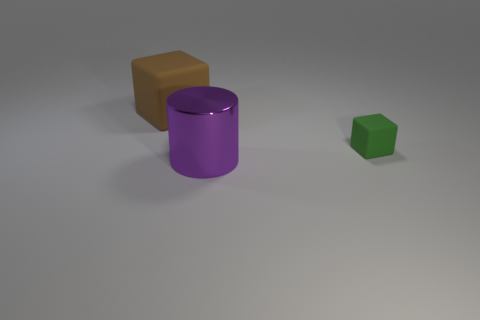The purple metal thing that is the same size as the brown rubber object is what shape?
Your response must be concise. Cylinder. Is there a purple shiny block of the same size as the brown cube?
Ensure brevity in your answer.  No. Is the number of purple objects behind the brown object the same as the number of things in front of the green matte cube?
Make the answer very short. No. Is the cube to the left of the metal cylinder made of the same material as the thing that is in front of the green matte object?
Offer a terse response. No. What is the small thing made of?
Give a very brief answer. Rubber. How many other objects are there of the same color as the shiny object?
Provide a succinct answer. 0. Do the tiny rubber thing and the shiny cylinder have the same color?
Provide a succinct answer. No. How many large brown cubes are there?
Offer a terse response. 1. There is a object that is in front of the small object to the right of the big cylinder; what is it made of?
Make the answer very short. Metal. What material is the block that is the same size as the metal cylinder?
Give a very brief answer. Rubber. 